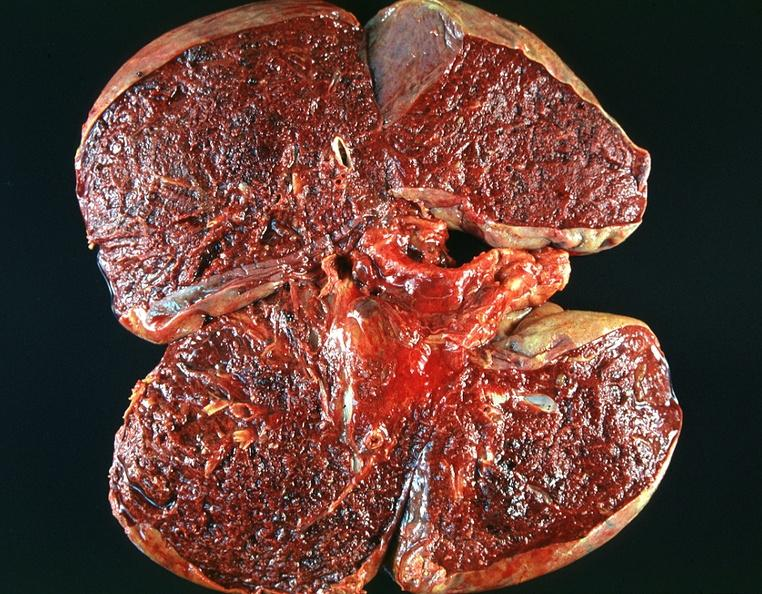how many antitrypsin does this image show lung, emphysema and pneumonia, alpha-deficiency?
Answer the question using a single word or phrase. 1 